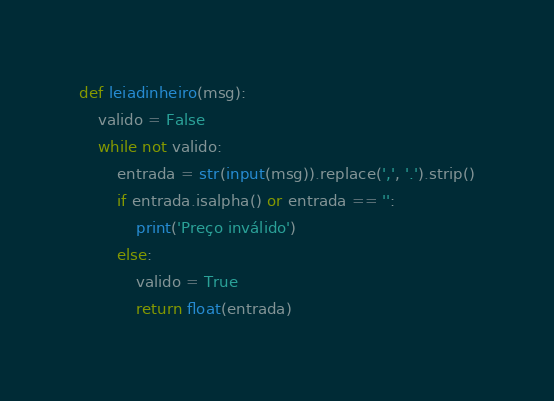Convert code to text. <code><loc_0><loc_0><loc_500><loc_500><_Python_>def leiadinheiro(msg):
    valido = False
    while not valido:
        entrada = str(input(msg)).replace(',', '.').strip()
        if entrada.isalpha() or entrada == '':
            print('Preço inválido')
        else:
            valido = True
            return float(entrada)
</code> 